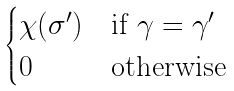Convert formula to latex. <formula><loc_0><loc_0><loc_500><loc_500>\begin{cases} \chi ( \sigma ^ { \prime } ) & \text {if } \gamma = \gamma ^ { \prime } \\ 0 & \text {otherwise } \end{cases}</formula> 